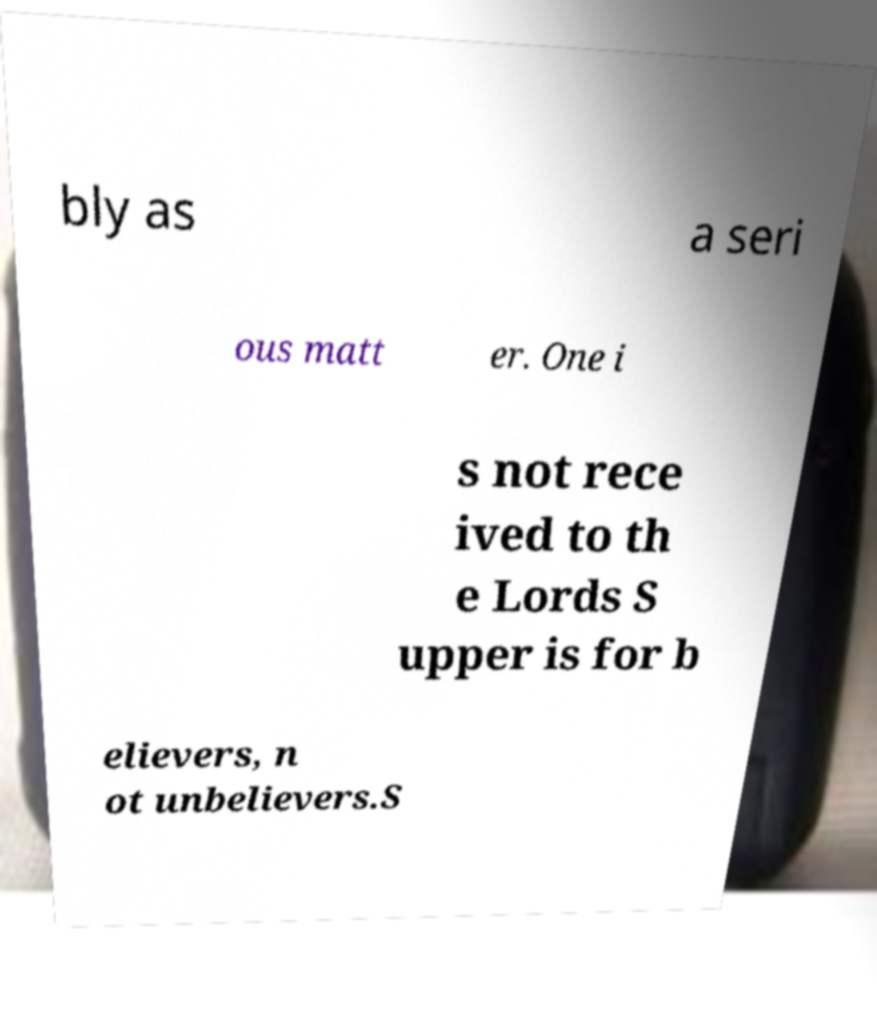For documentation purposes, I need the text within this image transcribed. Could you provide that? bly as a seri ous matt er. One i s not rece ived to th e Lords S upper is for b elievers, n ot unbelievers.S 